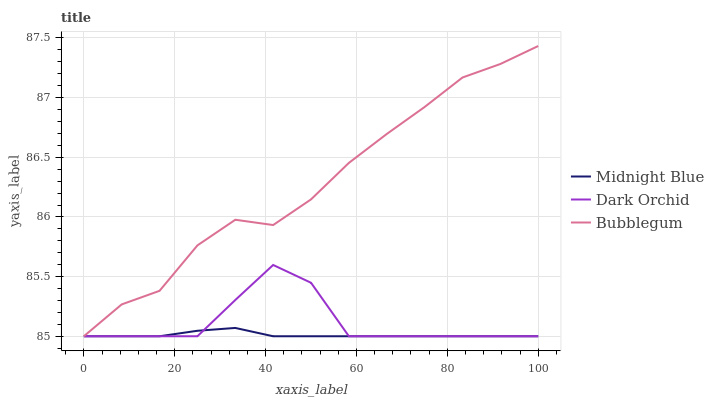Does Midnight Blue have the minimum area under the curve?
Answer yes or no. Yes. Does Bubblegum have the maximum area under the curve?
Answer yes or no. Yes. Does Dark Orchid have the minimum area under the curve?
Answer yes or no. No. Does Dark Orchid have the maximum area under the curve?
Answer yes or no. No. Is Midnight Blue the smoothest?
Answer yes or no. Yes. Is Dark Orchid the roughest?
Answer yes or no. Yes. Is Dark Orchid the smoothest?
Answer yes or no. No. Is Midnight Blue the roughest?
Answer yes or no. No. Does Bubblegum have the highest value?
Answer yes or no. Yes. Does Dark Orchid have the highest value?
Answer yes or no. No. Does Dark Orchid intersect Bubblegum?
Answer yes or no. Yes. Is Dark Orchid less than Bubblegum?
Answer yes or no. No. Is Dark Orchid greater than Bubblegum?
Answer yes or no. No. 